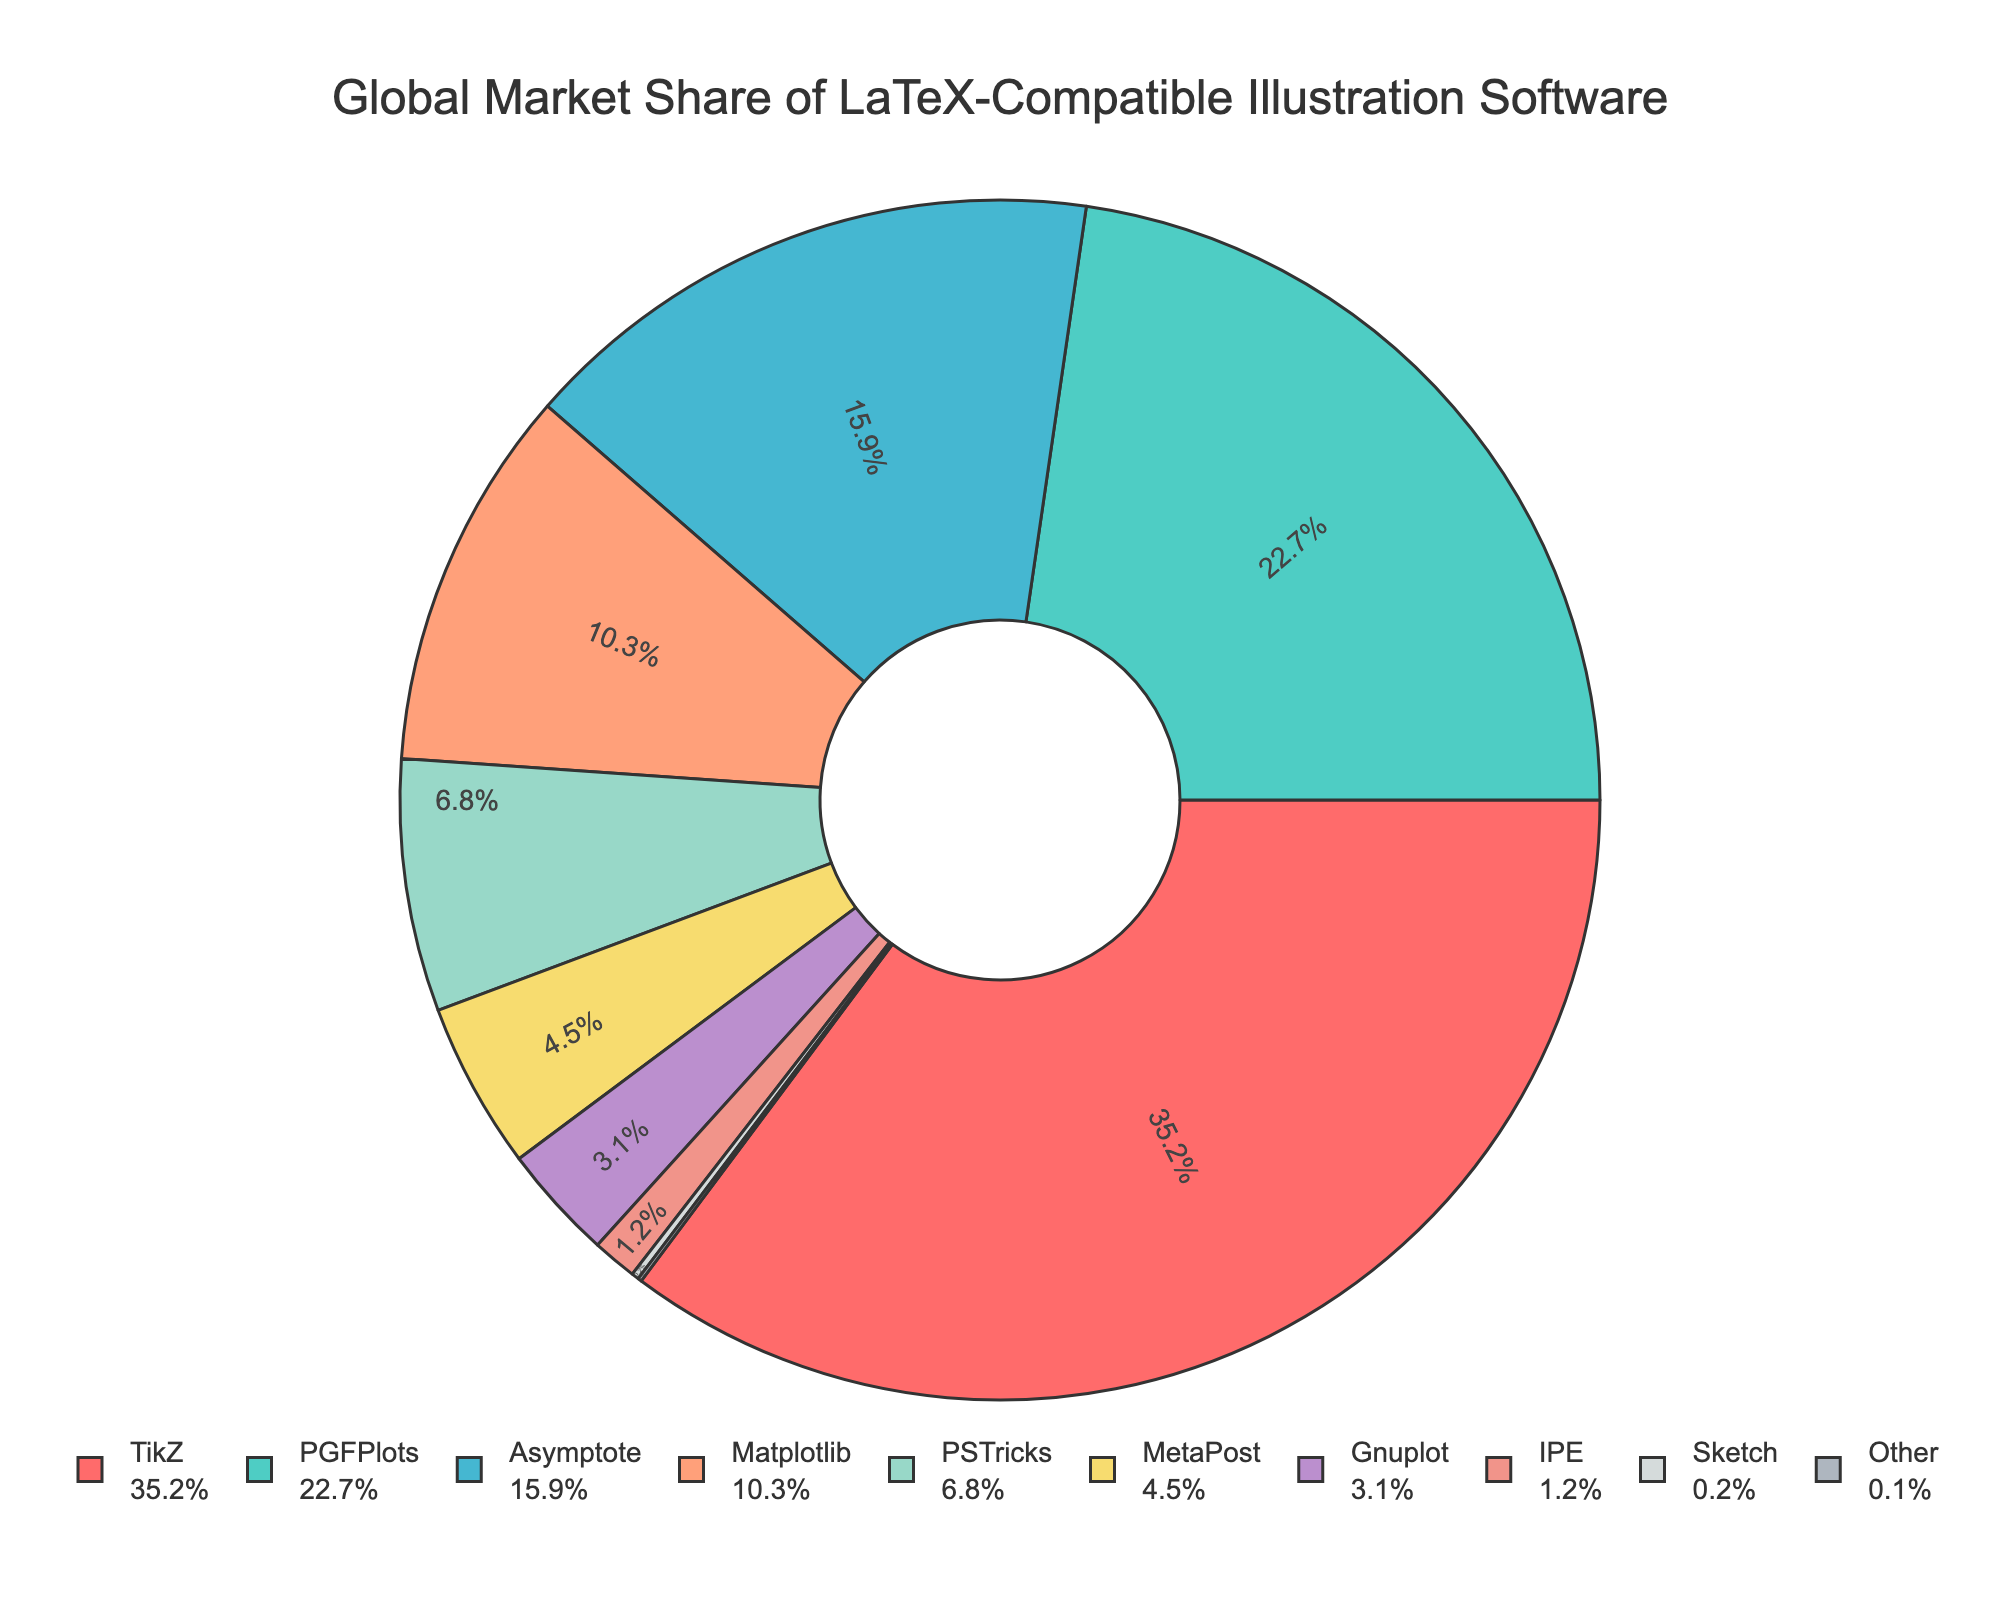What is the software with the largest market share? The figure shows the market shares of various LaTeX-compatible illustration software as sections of the pie chart, with TikZ labelled as the largest section with 35.2%.
Answer: TikZ What is the total market share of PGFPlots and Matplotlib combined? PGFPlots has a market share of 22.7%, and Matplotlib has 10.3%. Adding these together, 22.7 + 10.3 = 33%.
Answer: 33% Which software has a higher market share, Asymptote or PSTricks? The figure shows Asymptote with a market share of 15.9% and PSTricks with 6.8%. As 15.9% is greater than 6.8%, Asymptote has the higher market share.
Answer: Asymptote How much more market share does TikZ have compared to MetaPost? TikZ has a market share of 35.2%, and MetaPost has 4.5%. The difference is 35.2% - 4.5% = 30.7%.
Answer: 30.7% What is the average market share of the bottom five software? The bottom five software are MetaPost (4.5%), Gnuplot (3.1%), IPE (1.2%), Sketch (0.2%), and Other (0.1%). Adding them together: 4.5 + 3.1 + 1.2 + 0.2 + 0.1 = 9.1%. Dividing by 5, 9.1% / 5 = 1.82%.
Answer: 1.82% What is the color of the section representing PSTricks in the pie chart? The color for each section is clearly distinguishable in the pie chart. For PSTricks, it is a yellow color.
Answer: Yellow Which software resides in the largest green section of the pie chart? The largest green section of the pie chart represents PGFPlots, which stands out due to its size and color.
Answer: PGFPlots By how much does the market share of Matplotlib exceed that of Gnuplot? Matplotlib has a market share of 10.3%, and Gnuplot has 3.1%. The difference is 10.3% - 3.1% = 7.2%.
Answer: 7.2% Is the combined market share of MetaPost and Gnuplot greater than that of Asymptote? MetaPost has 4.5% and Gnuplot has 3.1%. Combined, their market share is 4.5% + 3.1% = 7.6%. Asymptote has a market share of 15.9%, which is greater than 7.6%.
Answer: No 